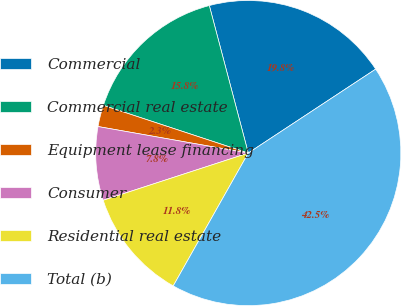Convert chart to OTSL. <chart><loc_0><loc_0><loc_500><loc_500><pie_chart><fcel>Commercial<fcel>Commercial real estate<fcel>Equipment lease financing<fcel>Consumer<fcel>Residential real estate<fcel>Total (b)<nl><fcel>19.84%<fcel>15.83%<fcel>2.28%<fcel>7.79%<fcel>11.81%<fcel>42.46%<nl></chart> 